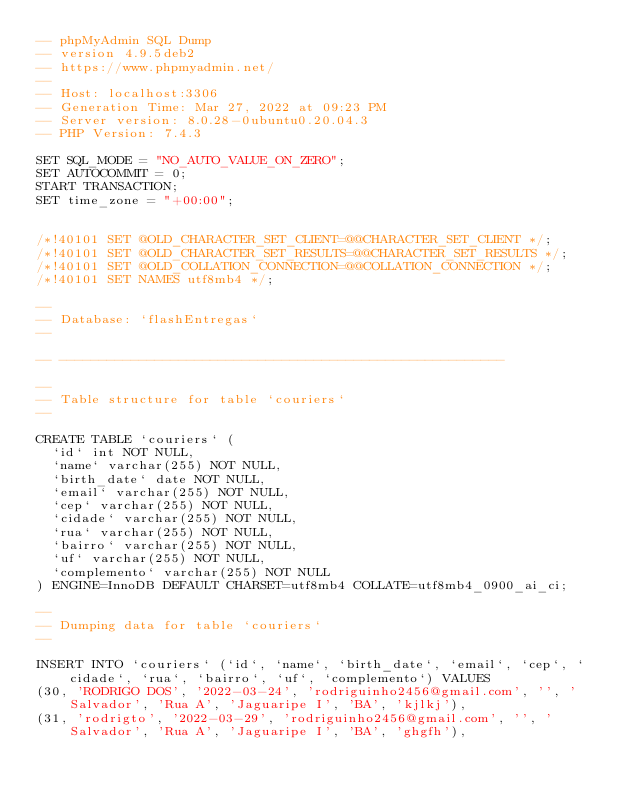Convert code to text. <code><loc_0><loc_0><loc_500><loc_500><_SQL_>-- phpMyAdmin SQL Dump
-- version 4.9.5deb2
-- https://www.phpmyadmin.net/
--
-- Host: localhost:3306
-- Generation Time: Mar 27, 2022 at 09:23 PM
-- Server version: 8.0.28-0ubuntu0.20.04.3
-- PHP Version: 7.4.3

SET SQL_MODE = "NO_AUTO_VALUE_ON_ZERO";
SET AUTOCOMMIT = 0;
START TRANSACTION;
SET time_zone = "+00:00";


/*!40101 SET @OLD_CHARACTER_SET_CLIENT=@@CHARACTER_SET_CLIENT */;
/*!40101 SET @OLD_CHARACTER_SET_RESULTS=@@CHARACTER_SET_RESULTS */;
/*!40101 SET @OLD_COLLATION_CONNECTION=@@COLLATION_CONNECTION */;
/*!40101 SET NAMES utf8mb4 */;

--
-- Database: `flashEntregas`
--

-- --------------------------------------------------------

--
-- Table structure for table `couriers`
--

CREATE TABLE `couriers` (
  `id` int NOT NULL,
  `name` varchar(255) NOT NULL,
  `birth_date` date NOT NULL,
  `email` varchar(255) NOT NULL,
  `cep` varchar(255) NOT NULL,
  `cidade` varchar(255) NOT NULL,
  `rua` varchar(255) NOT NULL,
  `bairro` varchar(255) NOT NULL,
  `uf` varchar(255) NOT NULL,
  `complemento` varchar(255) NOT NULL
) ENGINE=InnoDB DEFAULT CHARSET=utf8mb4 COLLATE=utf8mb4_0900_ai_ci;

--
-- Dumping data for table `couriers`
--

INSERT INTO `couriers` (`id`, `name`, `birth_date`, `email`, `cep`, `cidade`, `rua`, `bairro`, `uf`, `complemento`) VALUES
(30, 'RODRIGO DOS', '2022-03-24', 'rodriguinho2456@gmail.com', '', 'Salvador', 'Rua A', 'Jaguaripe I', 'BA', 'kjlkj'),
(31, 'rodrigto', '2022-03-29', 'rodriguinho2456@gmail.com', '', 'Salvador', 'Rua A', 'Jaguaripe I', 'BA', 'ghgfh'),</code> 